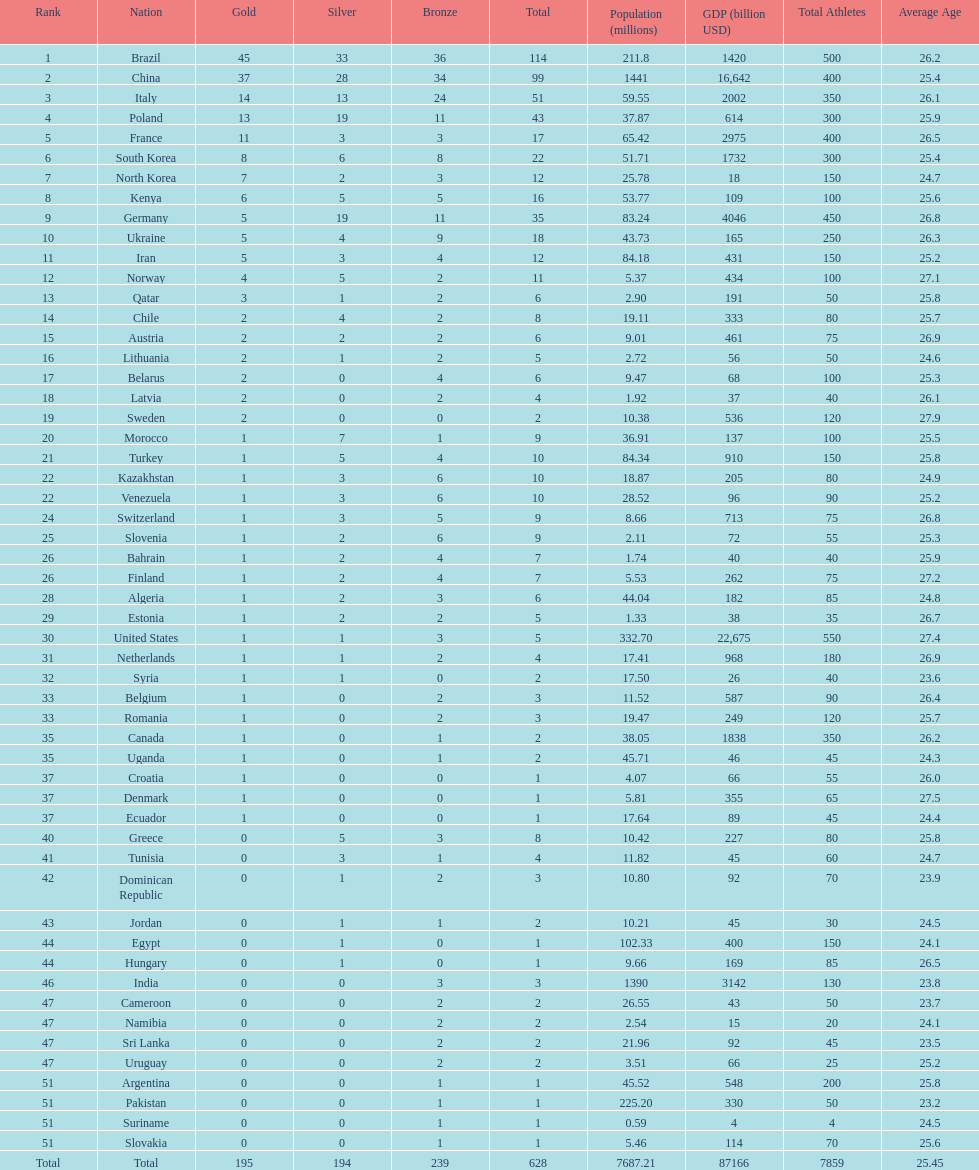Who won more gold medals, brazil or china? Brazil. 